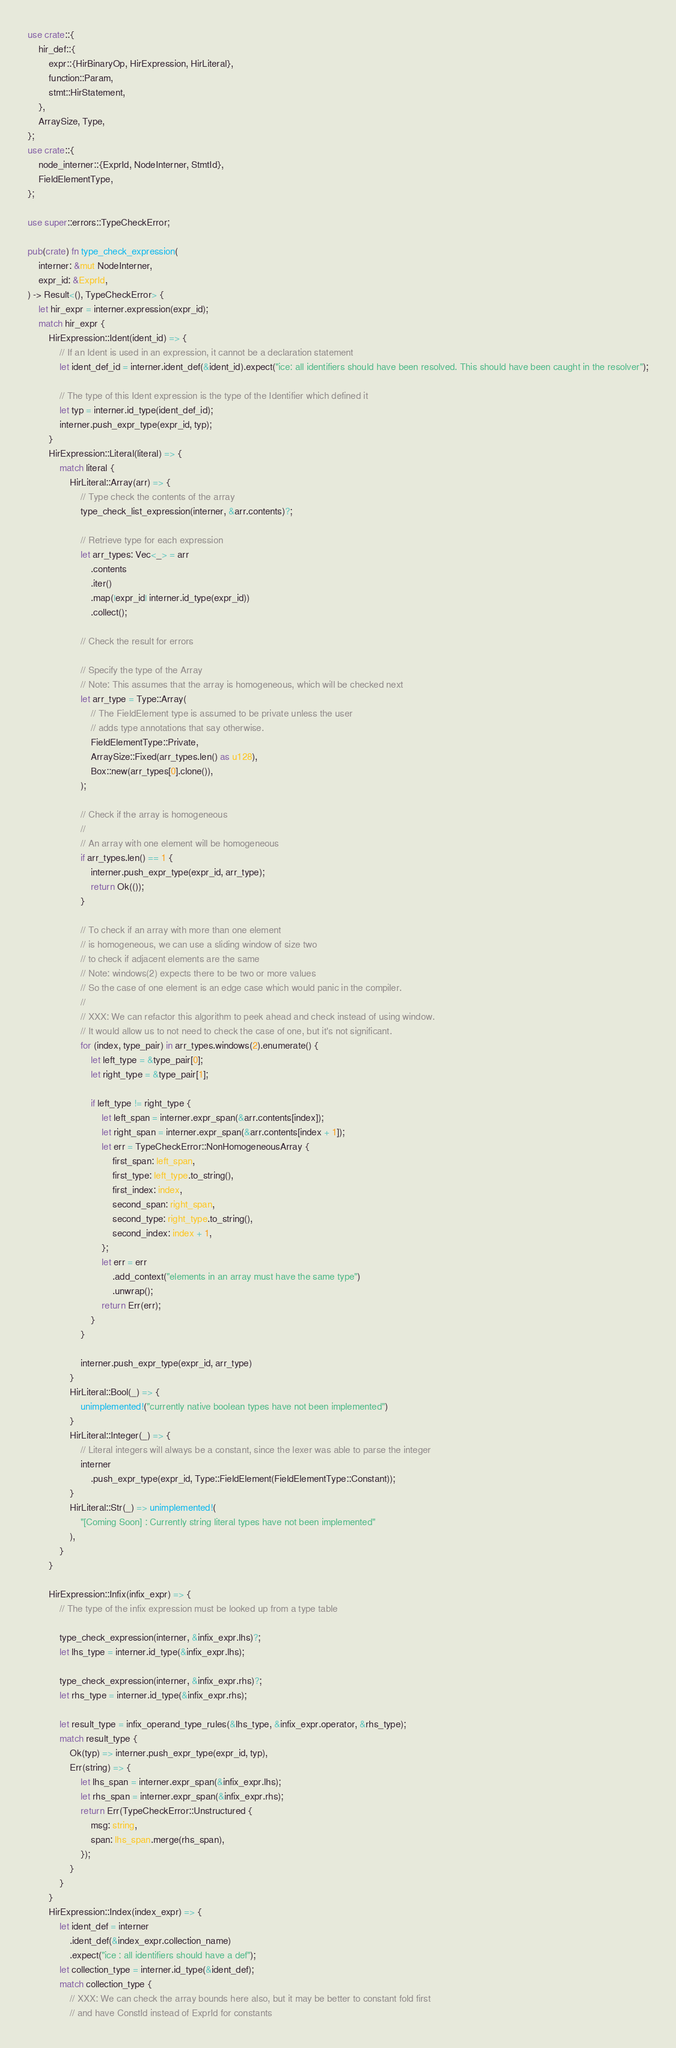<code> <loc_0><loc_0><loc_500><loc_500><_Rust_>use crate::{
    hir_def::{
        expr::{HirBinaryOp, HirExpression, HirLiteral},
        function::Param,
        stmt::HirStatement,
    },
    ArraySize, Type,
};
use crate::{
    node_interner::{ExprId, NodeInterner, StmtId},
    FieldElementType,
};

use super::errors::TypeCheckError;

pub(crate) fn type_check_expression(
    interner: &mut NodeInterner,
    expr_id: &ExprId,
) -> Result<(), TypeCheckError> {
    let hir_expr = interner.expression(expr_id);
    match hir_expr {
        HirExpression::Ident(ident_id) => {
            // If an Ident is used in an expression, it cannot be a declaration statement
            let ident_def_id = interner.ident_def(&ident_id).expect("ice: all identifiers should have been resolved. This should have been caught in the resolver");

            // The type of this Ident expression is the type of the Identifier which defined it
            let typ = interner.id_type(ident_def_id);
            interner.push_expr_type(expr_id, typ);
        }
        HirExpression::Literal(literal) => {
            match literal {
                HirLiteral::Array(arr) => {
                    // Type check the contents of the array
                    type_check_list_expression(interner, &arr.contents)?;

                    // Retrieve type for each expression
                    let arr_types: Vec<_> = arr
                        .contents
                        .iter()
                        .map(|expr_id| interner.id_type(expr_id))
                        .collect();

                    // Check the result for errors

                    // Specify the type of the Array
                    // Note: This assumes that the array is homogeneous, which will be checked next
                    let arr_type = Type::Array(
                        // The FieldElement type is assumed to be private unless the user
                        // adds type annotations that say otherwise.
                        FieldElementType::Private,
                        ArraySize::Fixed(arr_types.len() as u128),
                        Box::new(arr_types[0].clone()),
                    );

                    // Check if the array is homogeneous
                    //
                    // An array with one element will be homogeneous
                    if arr_types.len() == 1 {
                        interner.push_expr_type(expr_id, arr_type);
                        return Ok(());
                    }

                    // To check if an array with more than one element
                    // is homogeneous, we can use a sliding window of size two
                    // to check if adjacent elements are the same
                    // Note: windows(2) expects there to be two or more values
                    // So the case of one element is an edge case which would panic in the compiler.
                    //
                    // XXX: We can refactor this algorithm to peek ahead and check instead of using window.
                    // It would allow us to not need to check the case of one, but it's not significant.
                    for (index, type_pair) in arr_types.windows(2).enumerate() {
                        let left_type = &type_pair[0];
                        let right_type = &type_pair[1];

                        if left_type != right_type {
                            let left_span = interner.expr_span(&arr.contents[index]);
                            let right_span = interner.expr_span(&arr.contents[index + 1]);
                            let err = TypeCheckError::NonHomogeneousArray {
                                first_span: left_span,
                                first_type: left_type.to_string(),
                                first_index: index,
                                second_span: right_span,
                                second_type: right_type.to_string(),
                                second_index: index + 1,
                            };
                            let err = err
                                .add_context("elements in an array must have the same type")
                                .unwrap();
                            return Err(err);
                        }
                    }

                    interner.push_expr_type(expr_id, arr_type)
                }
                HirLiteral::Bool(_) => {
                    unimplemented!("currently native boolean types have not been implemented")
                }
                HirLiteral::Integer(_) => {
                    // Literal integers will always be a constant, since the lexer was able to parse the integer
                    interner
                        .push_expr_type(expr_id, Type::FieldElement(FieldElementType::Constant));
                }
                HirLiteral::Str(_) => unimplemented!(
                    "[Coming Soon] : Currently string literal types have not been implemented"
                ),
            }
        }

        HirExpression::Infix(infix_expr) => {
            // The type of the infix expression must be looked up from a type table

            type_check_expression(interner, &infix_expr.lhs)?;
            let lhs_type = interner.id_type(&infix_expr.lhs);

            type_check_expression(interner, &infix_expr.rhs)?;
            let rhs_type = interner.id_type(&infix_expr.rhs);

            let result_type = infix_operand_type_rules(&lhs_type, &infix_expr.operator, &rhs_type);
            match result_type {
                Ok(typ) => interner.push_expr_type(expr_id, typ),
                Err(string) => {
                    let lhs_span = interner.expr_span(&infix_expr.lhs);
                    let rhs_span = interner.expr_span(&infix_expr.rhs);
                    return Err(TypeCheckError::Unstructured {
                        msg: string,
                        span: lhs_span.merge(rhs_span),
                    });
                }
            }
        }
        HirExpression::Index(index_expr) => {
            let ident_def = interner
                .ident_def(&index_expr.collection_name)
                .expect("ice : all identifiers should have a def");
            let collection_type = interner.id_type(&ident_def);
            match collection_type {
                // XXX: We can check the array bounds here also, but it may be better to constant fold first
                // and have ConstId instead of ExprId for constants</code> 